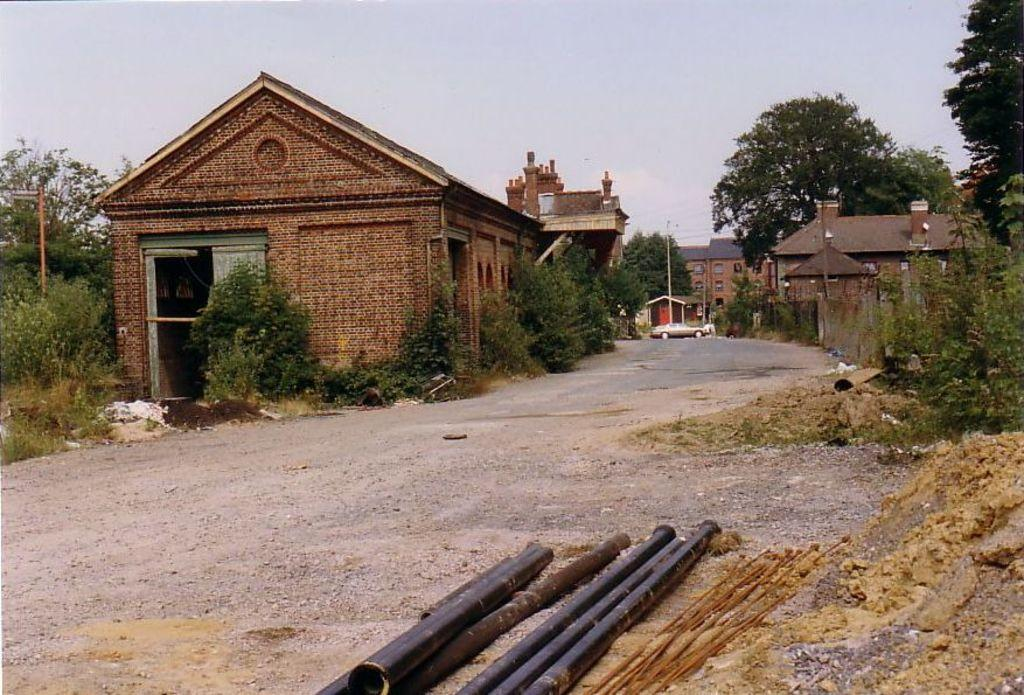What structures are located in the center of the image? There are sheds in the center of the image. What type of vehicle can be seen on the road in the image? There is a car on the road in the image. What objects are at the bottom of the image? There are rods at the bottom of the image. What type of natural scenery is visible in the background of the image? There are trees in the background of the image. What is visible in the sky in the background of the image? The sky is visible in the background of the image. What type of wood is the daughter holding in the image? There is no daughter or wood present in the image. What type of quiver is attached to the car in the image? There is no quiver present in the image, and the car does not have any attachments related to a quiver. 